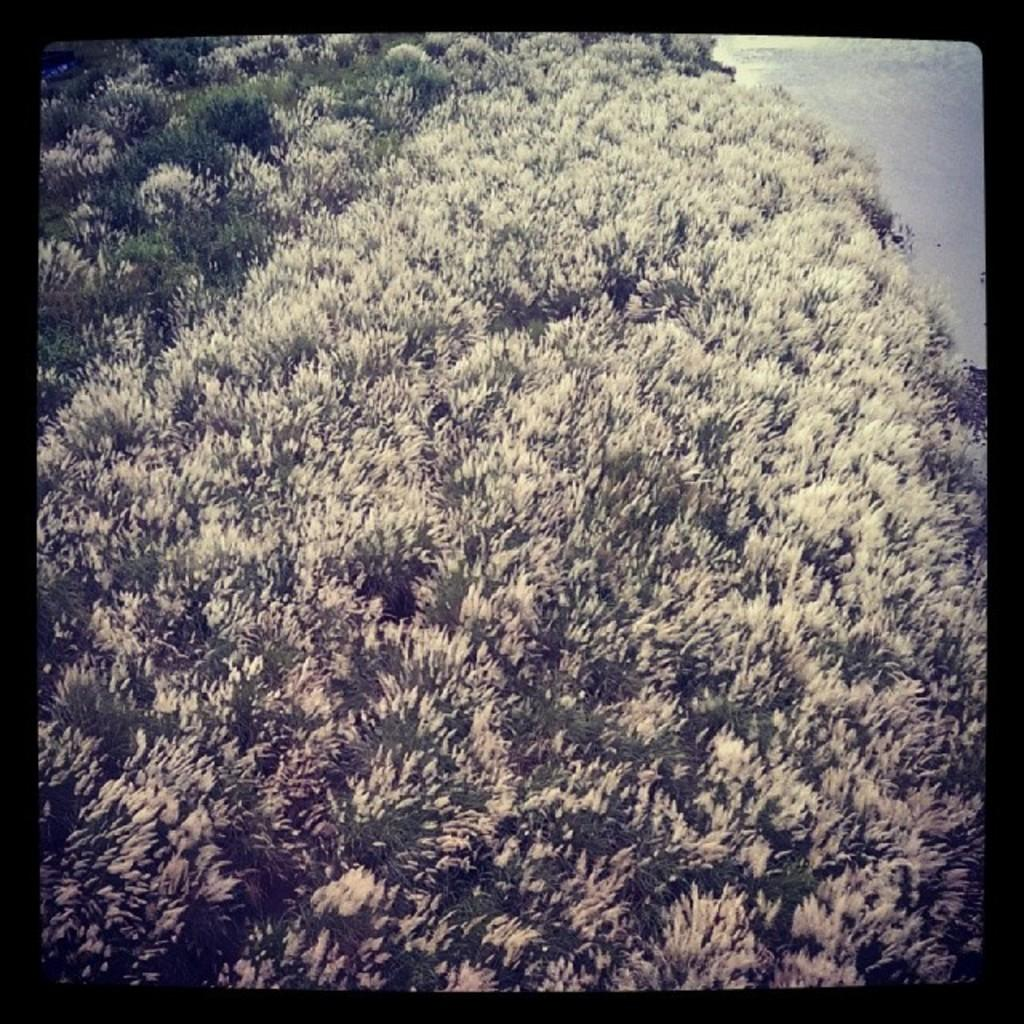What is the color of the borders surrounding the image? The image has black borders. Where was the image taken? The image was clicked outside. What can be seen in the center of the image? There are trees in the center of the image. What is visible in the background of the image? There is a water body in the background of the image. What language is spoken by the sister in the image? There is no sister present in the image, and therefore no language can be attributed to her. 